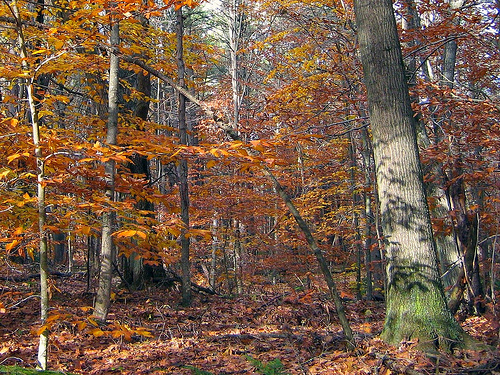<image>
Can you confirm if the leaves is under the tree? Yes. The leaves is positioned underneath the tree, with the tree above it in the vertical space. 